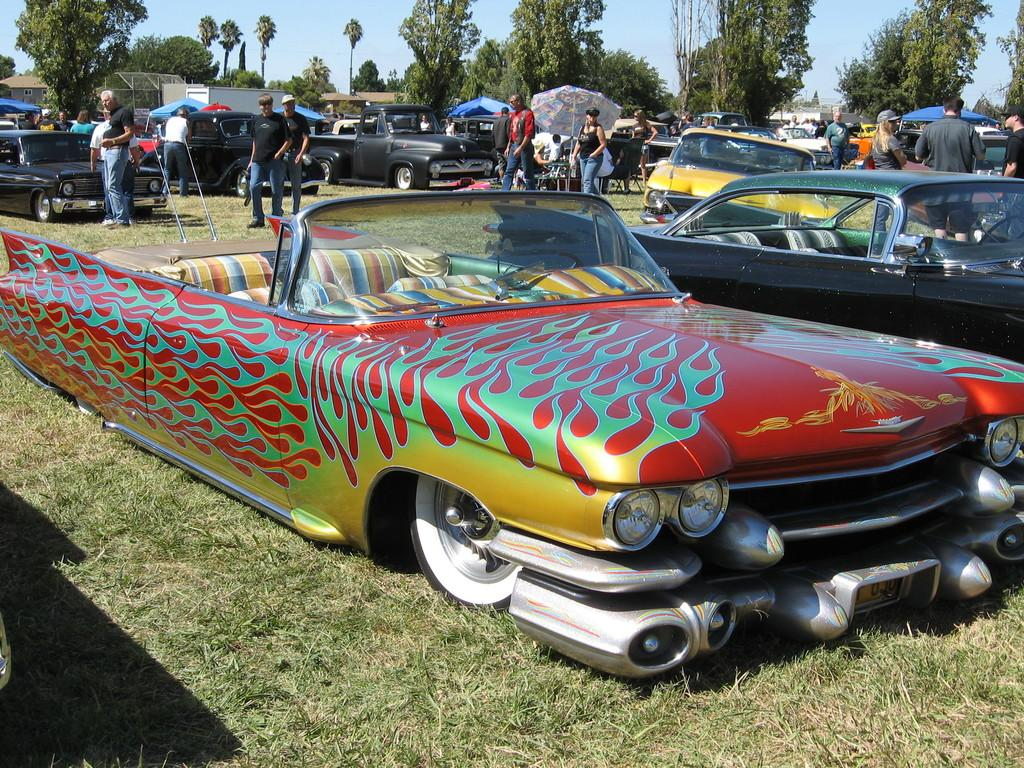Who or what can be seen in the image? There are people in the image. What is an unusual feature of the image? Vehicles are present on the grass. What object is used for shade in the image? There is an umbrella in the image. What structures can be seen in the distance? Houses are visible in the background of the image. What type of natural environment is visible in the background? Trees and the sky are visible in the background of the image. What type of bit is being used by the farmer in the image? There is no farmer or bit present in the image. What is the aftermath of the event depicted in the image? There is no event or aftermath depicted in the image; it simply shows people, vehicles, an umbrella, houses, trees, and the sky. 